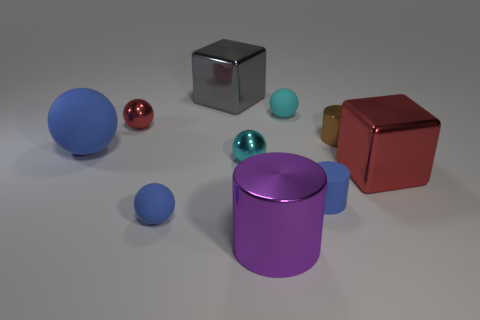Subtract all blocks. How many objects are left? 8 Subtract all purple cylinders. How many cylinders are left? 2 Subtract all small blue balls. How many balls are left? 4 Subtract 4 spheres. How many spheres are left? 1 Subtract all blue cylinders. How many blue balls are left? 2 Subtract all brown things. Subtract all large purple shiny things. How many objects are left? 8 Add 5 shiny spheres. How many shiny spheres are left? 7 Add 7 small red objects. How many small red objects exist? 8 Subtract 0 green cylinders. How many objects are left? 10 Subtract all brown cylinders. Subtract all red cubes. How many cylinders are left? 2 